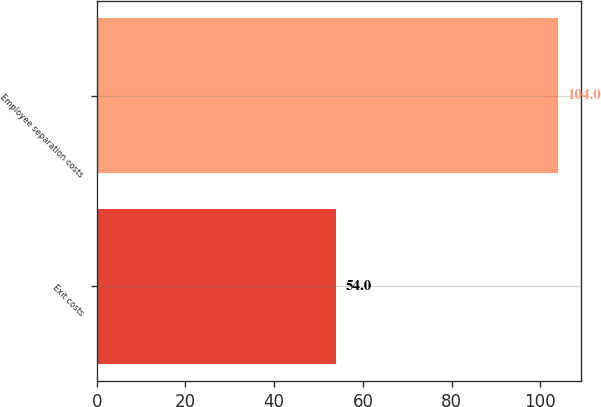Convert chart to OTSL. <chart><loc_0><loc_0><loc_500><loc_500><bar_chart><fcel>Exit costs<fcel>Employee separation costs<nl><fcel>54<fcel>104<nl></chart> 